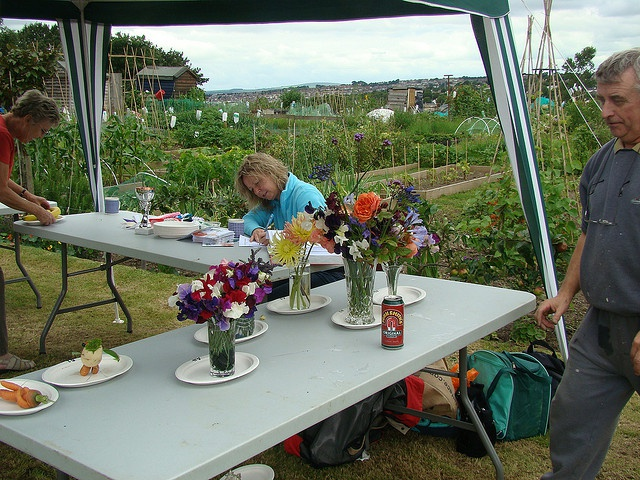Describe the objects in this image and their specific colors. I can see dining table in black, darkgray, and lightgray tones, people in black, gray, and olive tones, dining table in black, darkgray, gray, and olive tones, backpack in black, maroon, brown, and darkgray tones, and potted plant in black, maroon, darkgray, and gray tones in this image. 